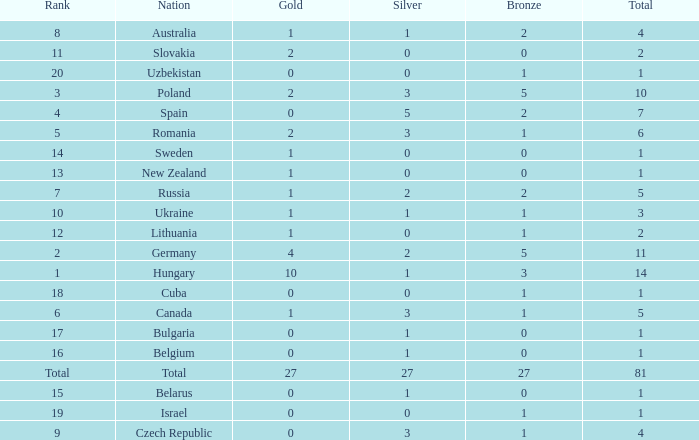How much Bronze has a Gold larger than 1, and a Silver smaller than 3, and a Nation of germany, and a Total larger than 11? 0.0. 